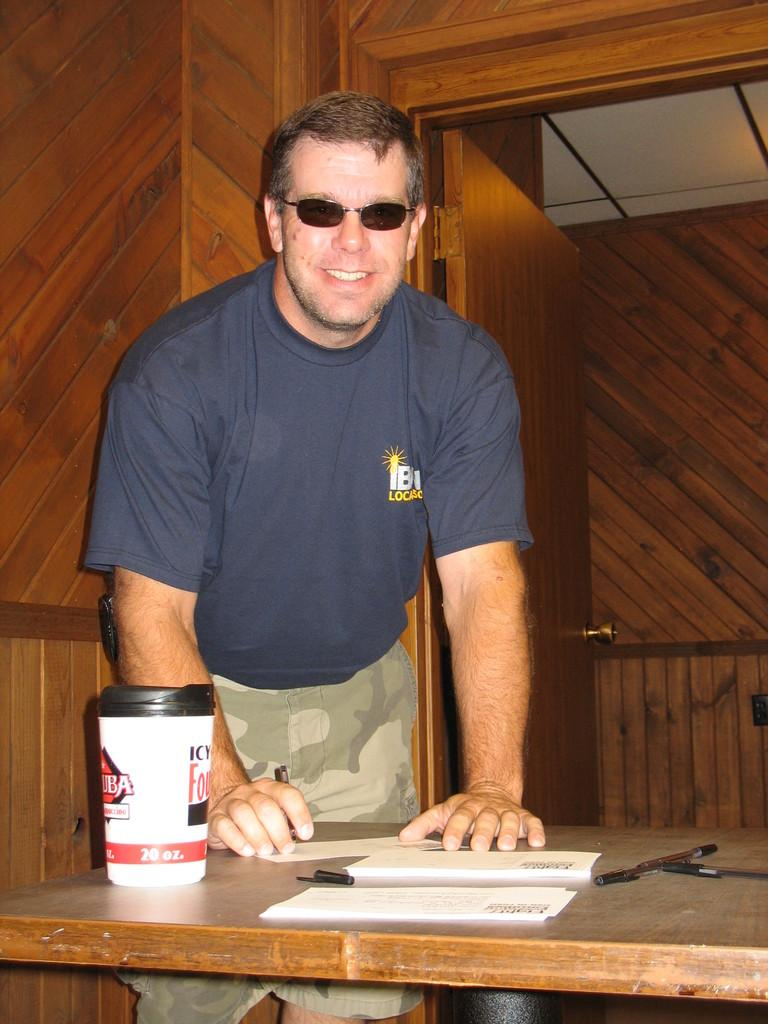Who is present in the image? There is a man in the image. What is the man wearing? The man is wearing spectacles. What is the man's facial expression? The man is smiling. What can be seen on the table in the image? There is a bottle and papers on the table. What is visible in the background of the image? There is a door visible in the background of the image. How many chickens are present in the image? There are no chickens present in the image. What type of power source is used to operate the pump in the image? There is no pump present in the image. 